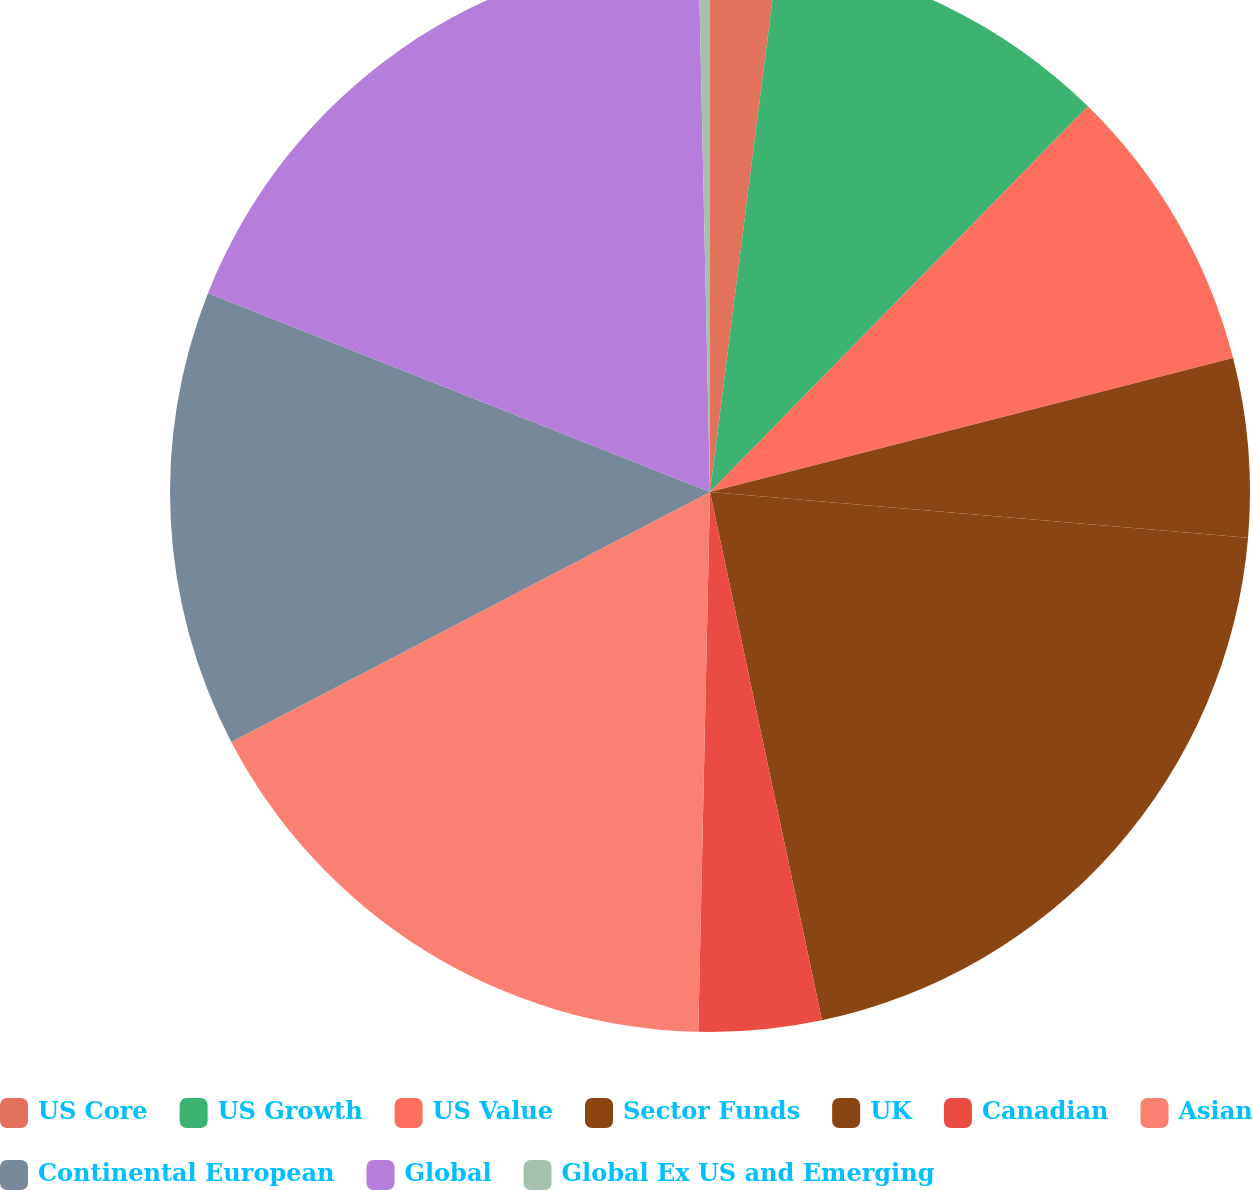Convert chart. <chart><loc_0><loc_0><loc_500><loc_500><pie_chart><fcel>US Core<fcel>US Growth<fcel>US Value<fcel>Sector Funds<fcel>UK<fcel>Canadian<fcel>Asian<fcel>Continental European<fcel>Global<fcel>Global Ex US and Emerging<nl><fcel>2.01%<fcel>10.33%<fcel>8.67%<fcel>5.34%<fcel>20.33%<fcel>3.67%<fcel>17.0%<fcel>13.66%<fcel>18.66%<fcel>0.34%<nl></chart> 